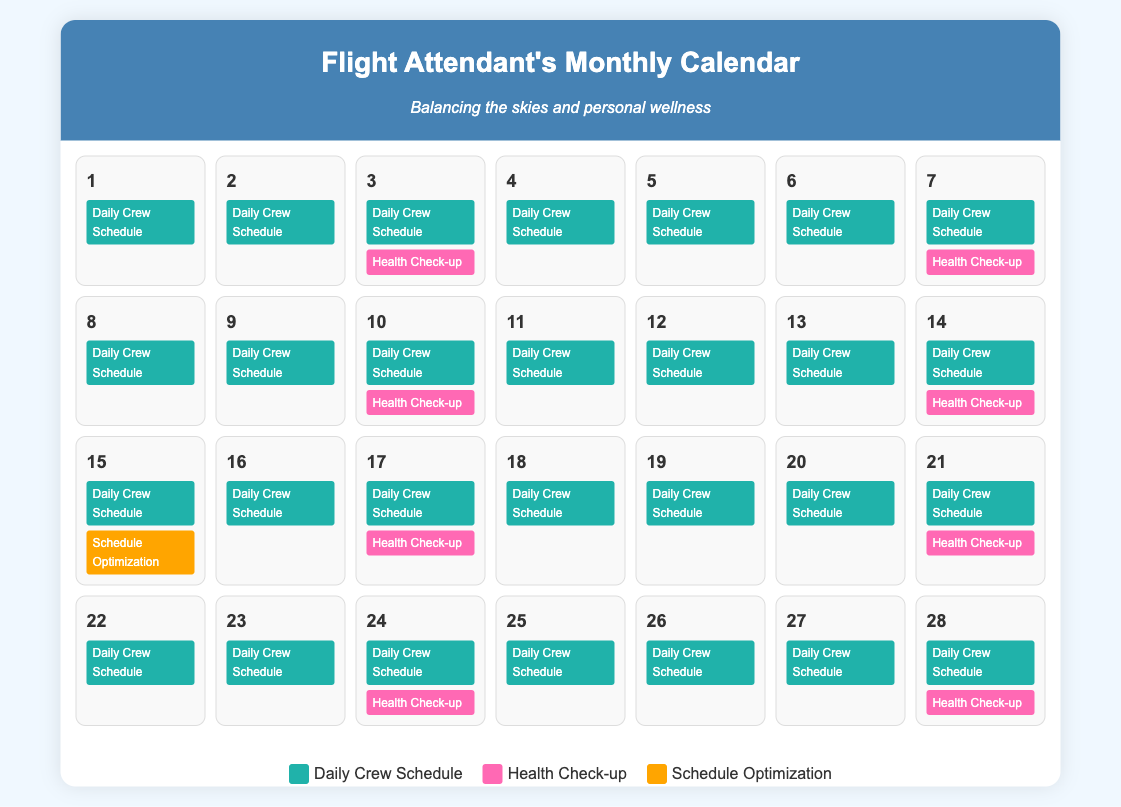What is the title of the document? The title of the document is specified in the `<title>` tag of the HTML, which is "Flight Attendant's Calendar".
Answer: Flight Attendant's Calendar How many health check-ups are scheduled? The health check-ups are indicated by the "Health Check-up" events in the calendar. There are a total of 5 scheduled.
Answer: 5 On which date is the first health check-up? The first health check-up appears on the 3rd day of the month in the calendar.
Answer: 3 What color represents the Daily Crew Schedule? The legend in the document indicates that the Daily Crew Schedule is represented by a specific background color, which is a shade of teal.
Answer: Teal Which day includes a schedule optimization event? The schedule optimization event occurs on the 15th day of the month, as indicated in the calendar.
Answer: 15 How many days in total are there in the calendar? The calendar covers a complete month, hence it contains 28 days.
Answer: 28 What is the background color for health check-ups? The "Health Check-up" events are colored pink in the document as shown in the legend.
Answer: Pink 